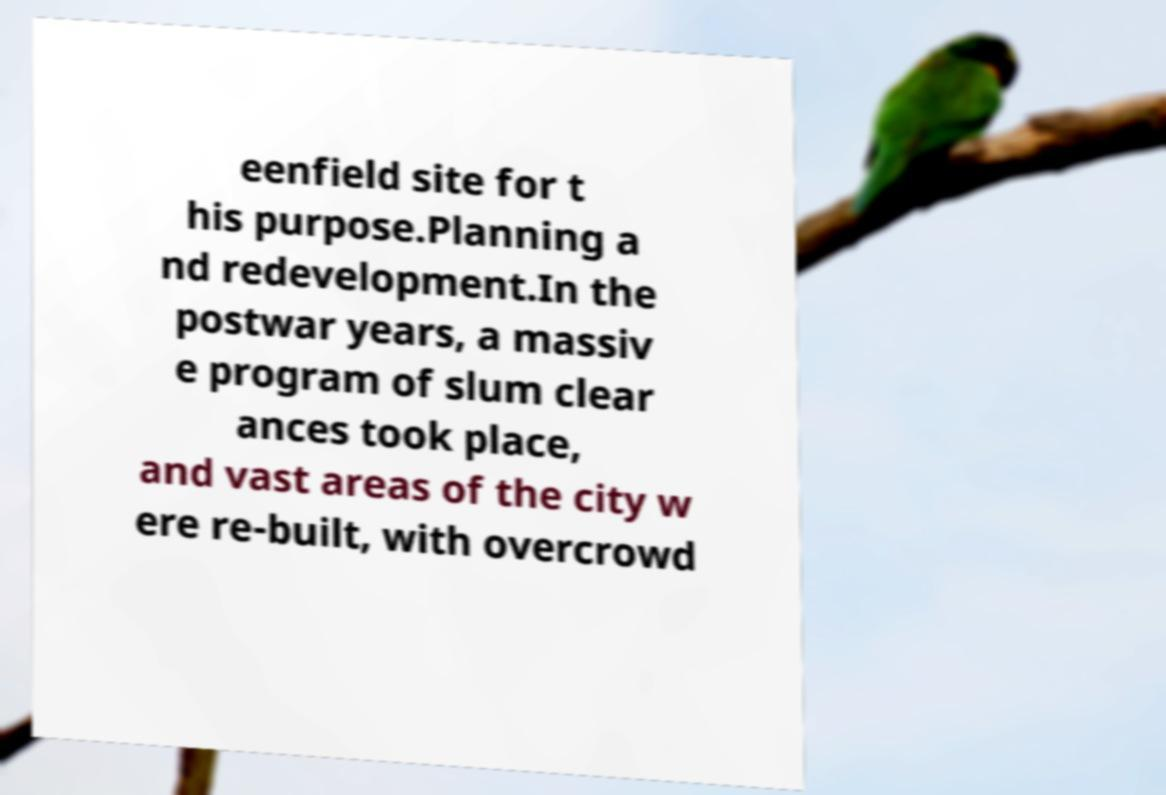Can you accurately transcribe the text from the provided image for me? eenfield site for t his purpose.Planning a nd redevelopment.In the postwar years, a massiv e program of slum clear ances took place, and vast areas of the city w ere re-built, with overcrowd 